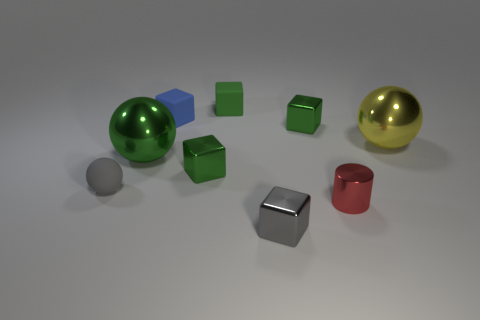What number of metal objects are large red objects or green spheres?
Your answer should be compact. 1. There is a small blue thing; what shape is it?
Your answer should be very brief. Cube. Do the cylinder and the big green sphere have the same material?
Keep it short and to the point. Yes. There is a metallic cube left of the tiny gray thing in front of the tiny gray ball; are there any balls in front of it?
Keep it short and to the point. Yes. How many other objects are there of the same shape as the small green matte thing?
Offer a terse response. 4. There is a object that is both to the right of the gray matte thing and to the left of the tiny blue rubber cube; what is its shape?
Offer a terse response. Sphere. There is a large metal thing in front of the big thing right of the large metal ball to the left of the small blue block; what color is it?
Offer a very short reply. Green. Is the number of big balls behind the tiny blue cube greater than the number of metallic spheres to the right of the large green sphere?
Provide a short and direct response. No. How many other objects are the same size as the yellow thing?
Provide a short and direct response. 1. The shiny cube that is the same color as the matte ball is what size?
Keep it short and to the point. Small. 